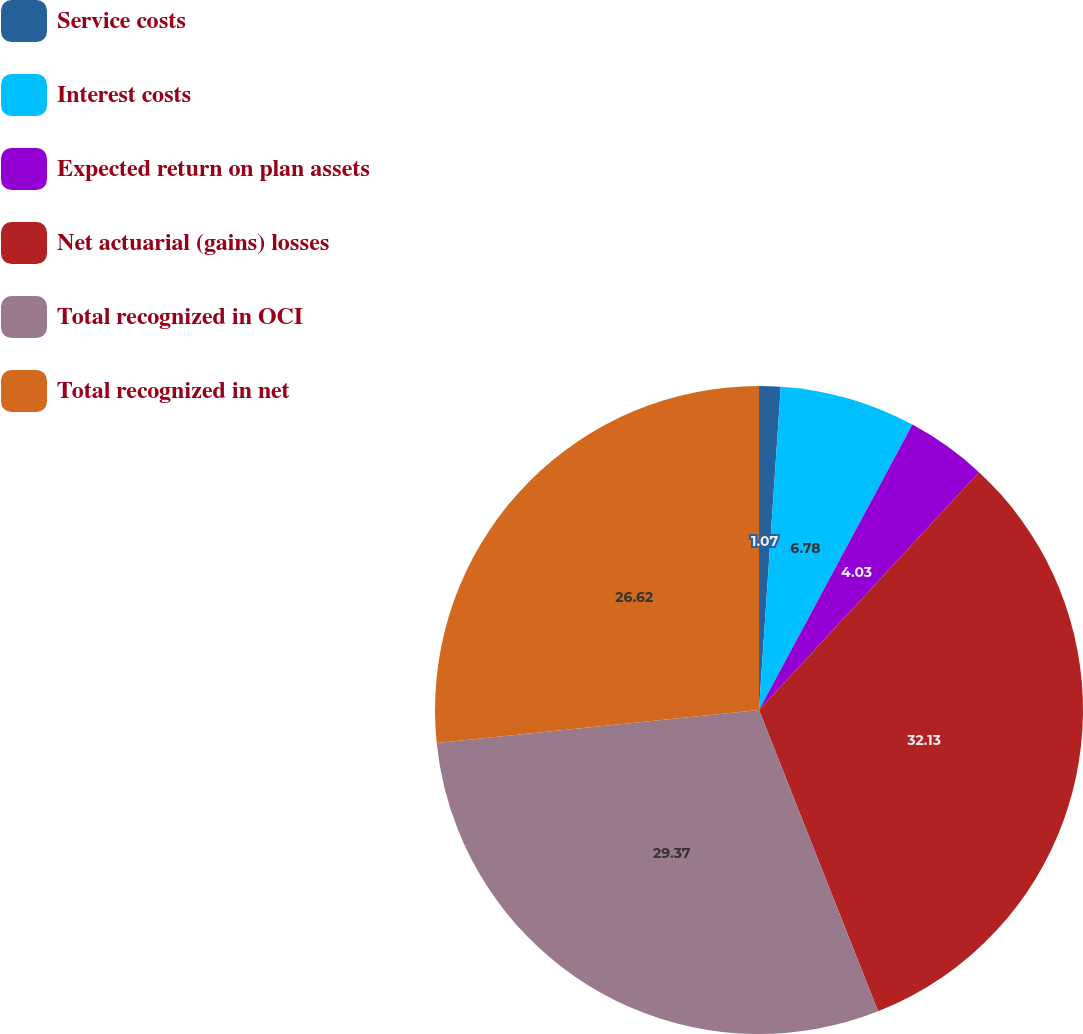Convert chart. <chart><loc_0><loc_0><loc_500><loc_500><pie_chart><fcel>Service costs<fcel>Interest costs<fcel>Expected return on plan assets<fcel>Net actuarial (gains) losses<fcel>Total recognized in OCI<fcel>Total recognized in net<nl><fcel>1.07%<fcel>6.78%<fcel>4.03%<fcel>32.13%<fcel>29.37%<fcel>26.62%<nl></chart> 